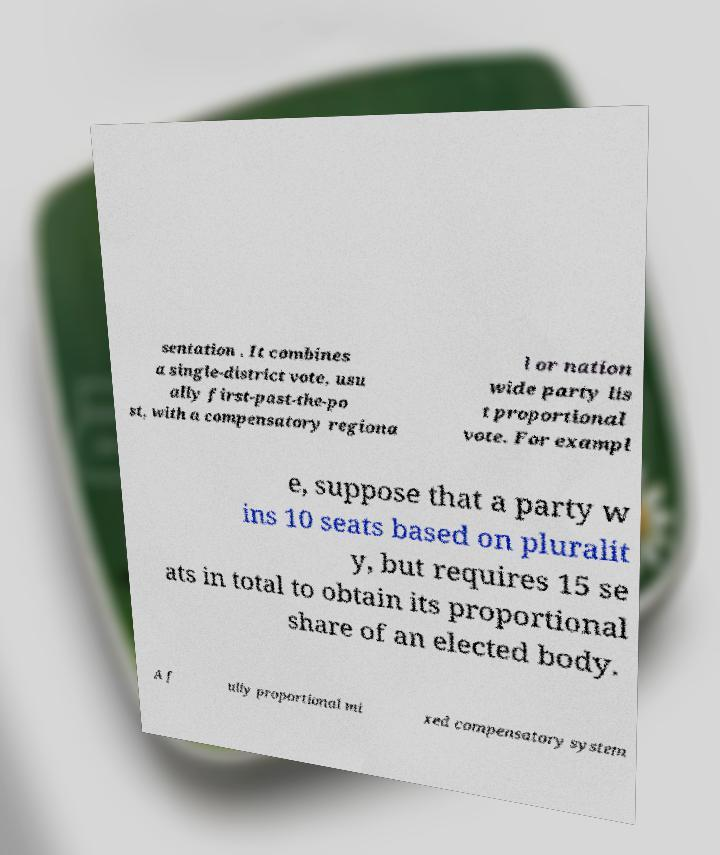What messages or text are displayed in this image? I need them in a readable, typed format. sentation . It combines a single-district vote, usu ally first-past-the-po st, with a compensatory regiona l or nation wide party lis t proportional vote. For exampl e, suppose that a party w ins 10 seats based on pluralit y, but requires 15 se ats in total to obtain its proportional share of an elected body. A f ully proportional mi xed compensatory system 